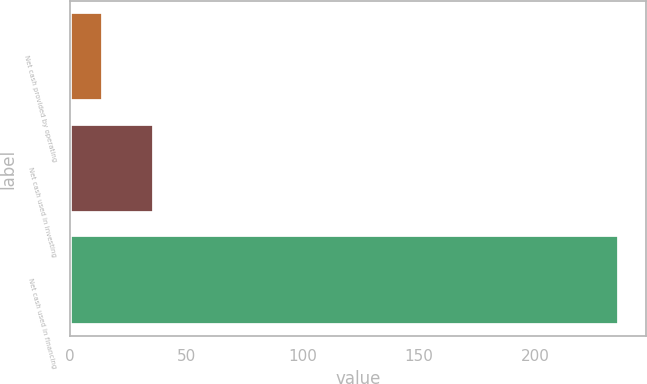Convert chart to OTSL. <chart><loc_0><loc_0><loc_500><loc_500><bar_chart><fcel>Net cash provided by operating<fcel>Net cash used in investing<fcel>Net cash used in financing<nl><fcel>14<fcel>36.2<fcel>236<nl></chart> 